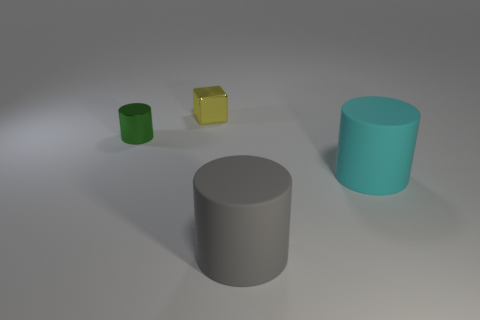There is a rubber thing right of the large rubber thing in front of the cyan rubber object; what size is it?
Give a very brief answer. Large. How many things are either cylinders to the right of the small yellow shiny cube or tiny yellow objects to the left of the cyan matte cylinder?
Offer a terse response. 3. Are there fewer big green rubber cubes than yellow cubes?
Keep it short and to the point. Yes. What number of things are big gray rubber objects or cyan matte cylinders?
Provide a short and direct response. 2. Is the shape of the green shiny thing the same as the tiny yellow shiny object?
Offer a terse response. No. Is there any other thing that has the same material as the cyan object?
Provide a short and direct response. Yes. Does the thing that is behind the tiny green cylinder have the same size as the metal thing that is in front of the small yellow thing?
Offer a terse response. Yes. There is a thing that is behind the cyan matte cylinder and in front of the tiny yellow metal thing; what material is it?
Provide a succinct answer. Metal. Are there any other things that have the same color as the cube?
Offer a very short reply. No. Is the number of gray rubber cylinders that are to the left of the big cyan cylinder less than the number of tiny purple metallic spheres?
Offer a very short reply. No. 